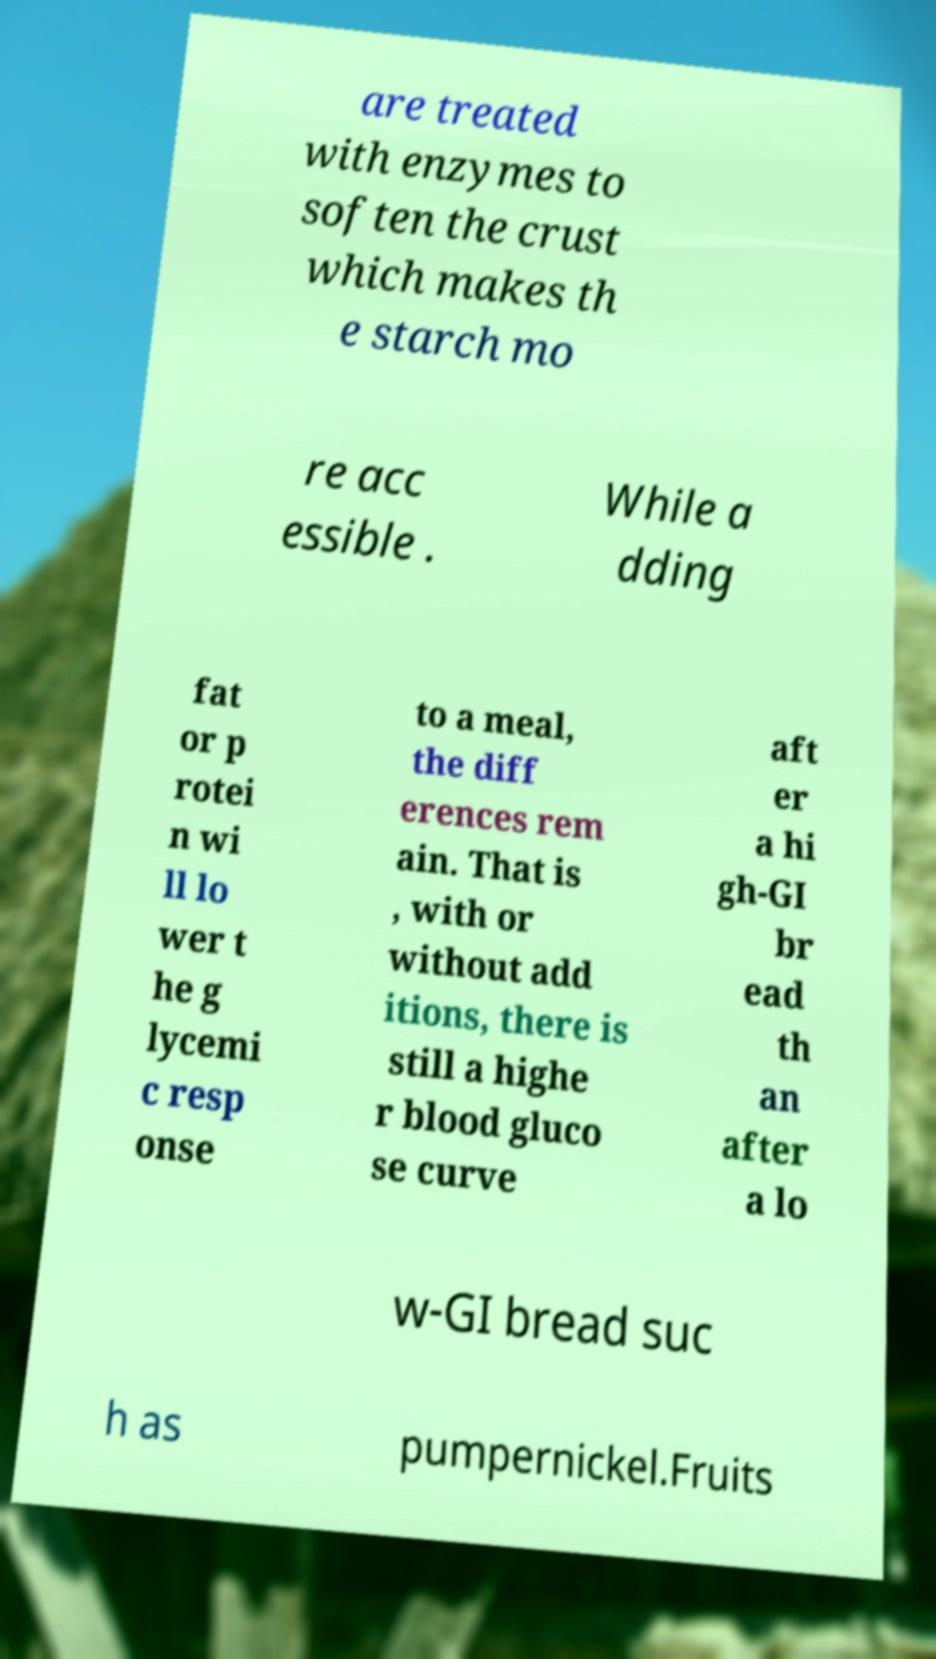Can you read and provide the text displayed in the image?This photo seems to have some interesting text. Can you extract and type it out for me? are treated with enzymes to soften the crust which makes th e starch mo re acc essible . While a dding fat or p rotei n wi ll lo wer t he g lycemi c resp onse to a meal, the diff erences rem ain. That is , with or without add itions, there is still a highe r blood gluco se curve aft er a hi gh-GI br ead th an after a lo w-GI bread suc h as pumpernickel.Fruits 